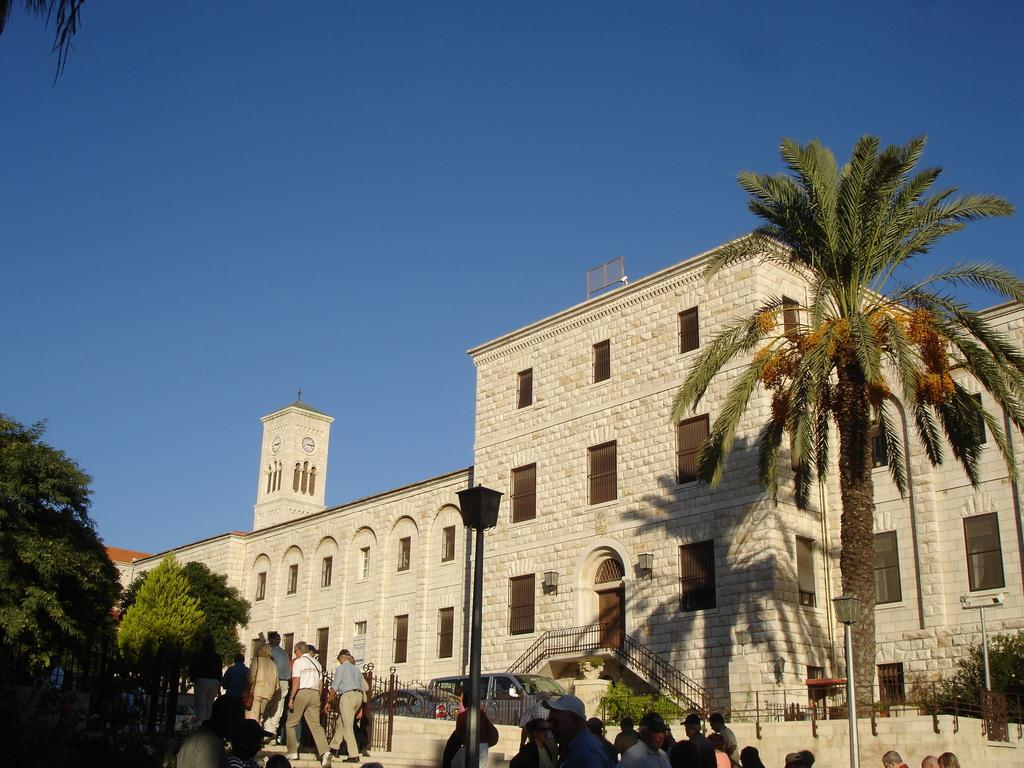What type of structure is visible in the image? There is a building in the image. How can people enter the building? The building has stairs for entering. What are the people in the image doing? People are moving on a sidewalk. What type of vegetation is present around the building? Trees are present around the building. What type of test is being conducted by the stranger in the image? There is no stranger or test present in the image. 